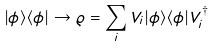<formula> <loc_0><loc_0><loc_500><loc_500>| \phi \rangle \langle \phi | \rightarrow \varrho = \sum _ { i } V _ { i } | \phi \rangle \langle \phi | V _ { i } ^ { \dagger }</formula> 